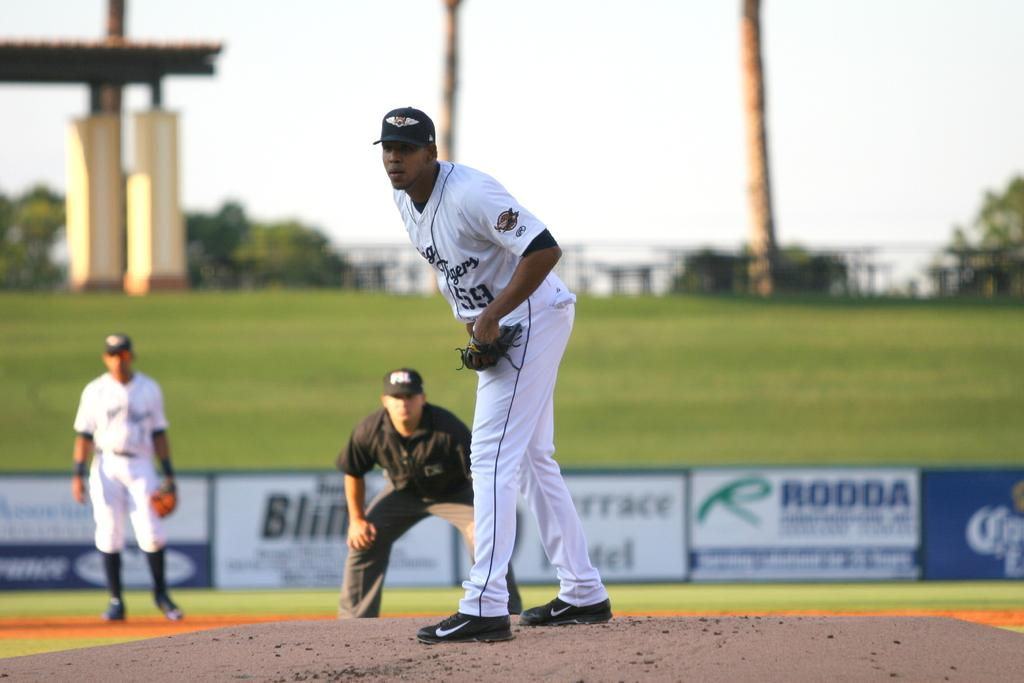<image>
Offer a succinct explanation of the picture presented. tigers player #59 getting ready to pitch baseball 